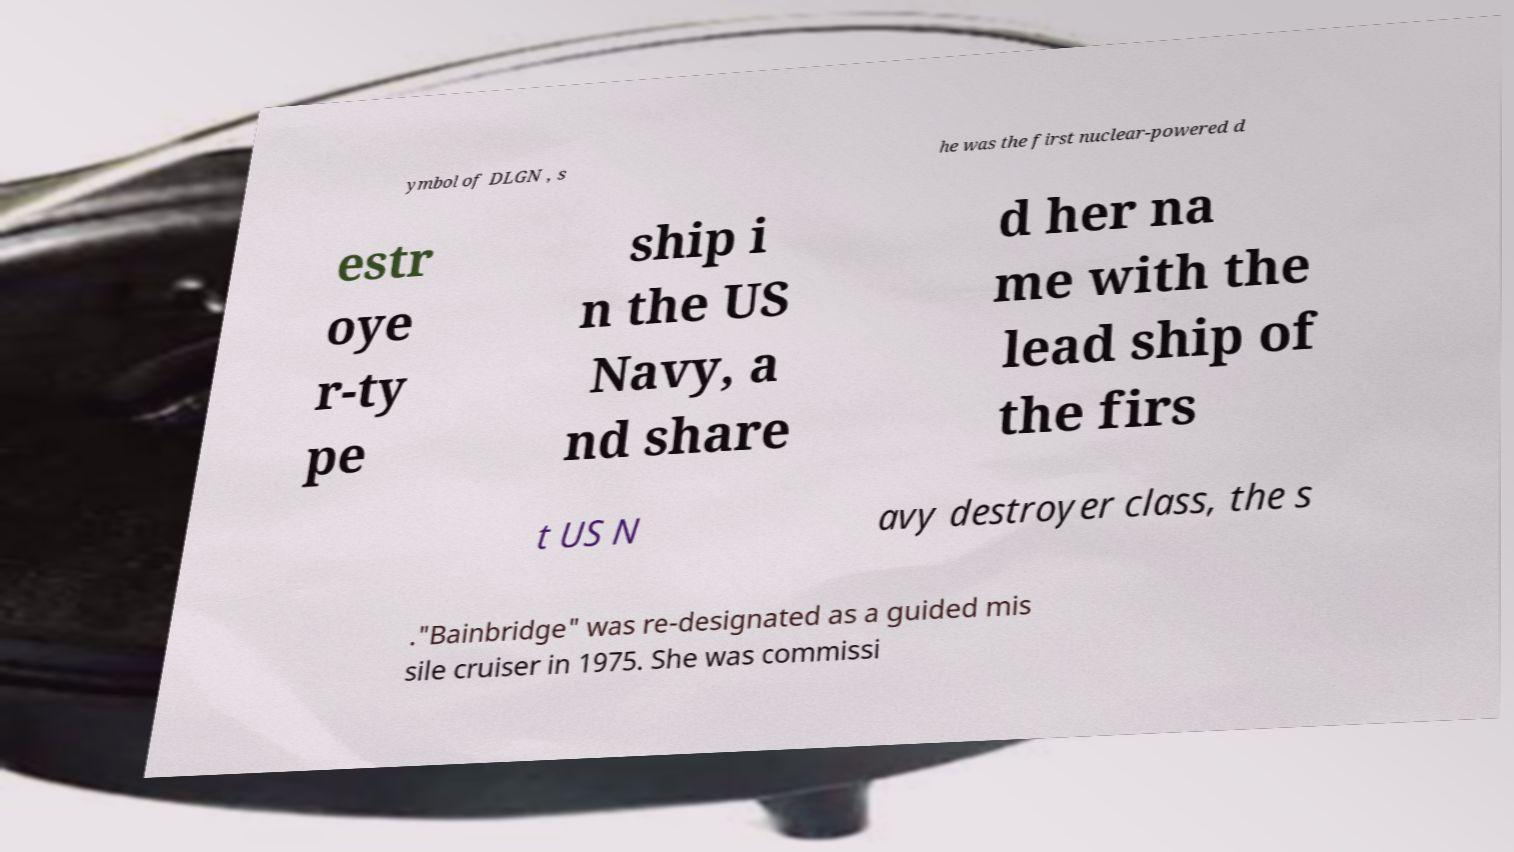Could you assist in decoding the text presented in this image and type it out clearly? ymbol of DLGN , s he was the first nuclear-powered d estr oye r-ty pe ship i n the US Navy, a nd share d her na me with the lead ship of the firs t US N avy destroyer class, the s ."Bainbridge" was re-designated as a guided mis sile cruiser in 1975. She was commissi 